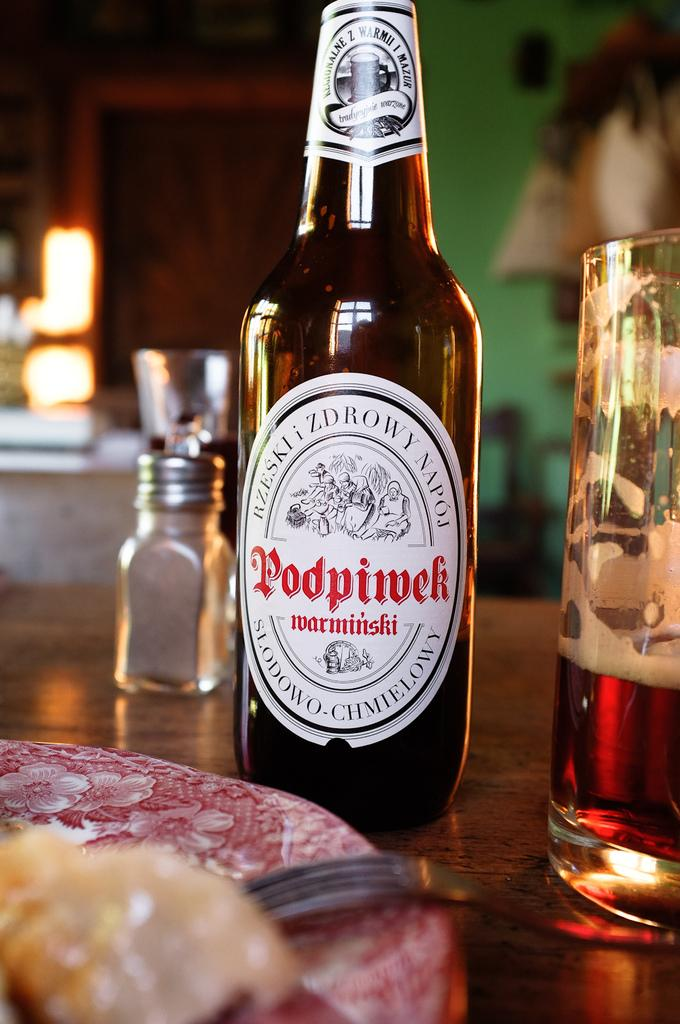<image>
Present a compact description of the photo's key features. A bottle of non-alcoholic Podpiwek is served in a glass on a wooden table. 